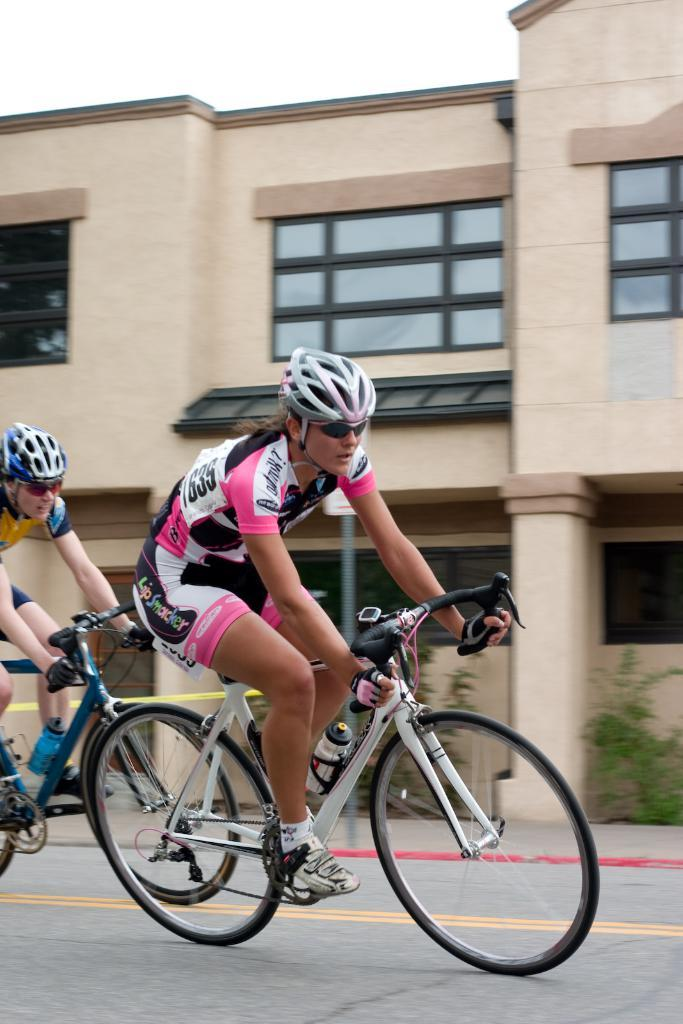How many people are in the image? There are two men in the image. What are the men doing in the image? The men are riding a bicycle. What safety precautions are the men taking while riding the bicycle? The men are wearing helmets. What type of eyewear are the men wearing? The men are wearing spectacles. Where is the scene taking place? The scene takes place on a road. What can be seen in the background of the image? There is a building, plants, and the sky visible in the background of the image. What type of cast can be seen on the men's arms in the image? There is no cast visible on the men's arms in the image. Is there a bridge in the background of the image? No, there is no bridge present in the image. 